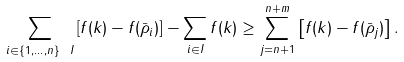<formula> <loc_0><loc_0><loc_500><loc_500>\sum _ { i \in \{ 1 , \dots , n \} \ I } \left [ f ( k ) - f ( \bar { \rho } _ { i } ) \right ] - \sum _ { i \in I } f ( k ) \geq \sum _ { j = n + 1 } ^ { n + m } \left [ f ( k ) - f ( \bar { \rho } _ { j } ) \right ] .</formula> 